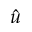<formula> <loc_0><loc_0><loc_500><loc_500>\hat { u }</formula> 